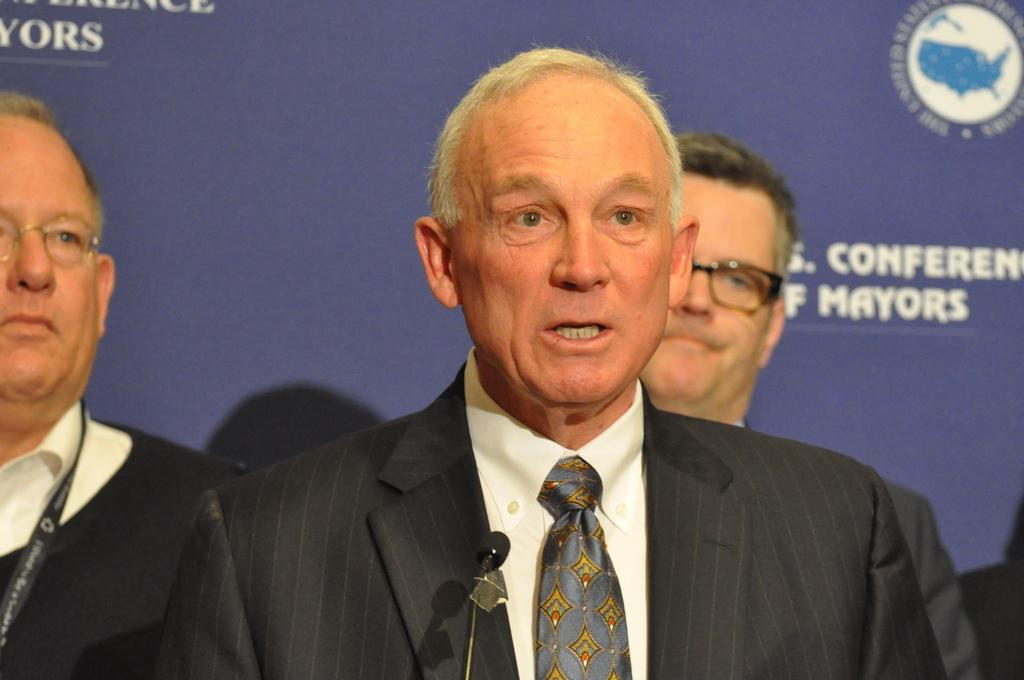How many people are in the image? There are three persons standing in the image. What can be seen behind the people? There is a poster visible behind the people. What is written on the poster? There is writing on the poster. What type of leather material is used to make the pen in the image? There is no pen present in the image, so it is not possible to determine the type of leather material used. 